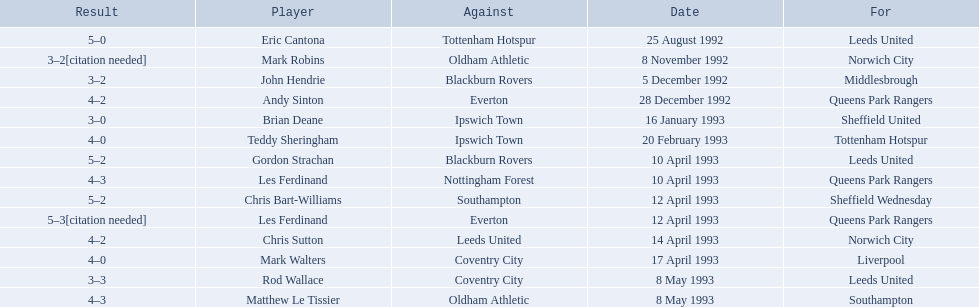Who are all the players? Eric Cantona, Mark Robins, John Hendrie, Andy Sinton, Brian Deane, Teddy Sheringham, Gordon Strachan, Les Ferdinand, Chris Bart-Williams, Les Ferdinand, Chris Sutton, Mark Walters, Rod Wallace, Matthew Le Tissier. What were their results? 5–0, 3–2[citation needed], 3–2, 4–2, 3–0, 4–0, 5–2, 4–3, 5–2, 5–3[citation needed], 4–2, 4–0, 3–3, 4–3. Which player tied with mark robins? John Hendrie. 